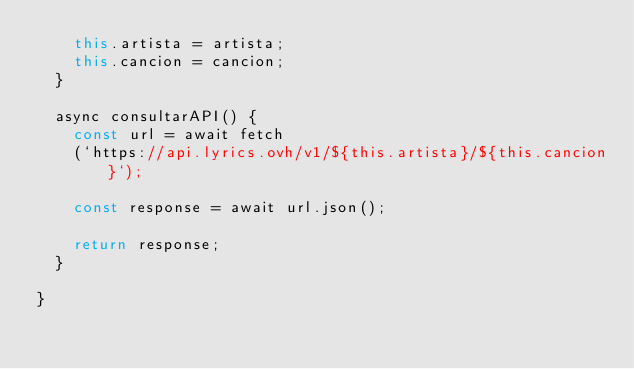<code> <loc_0><loc_0><loc_500><loc_500><_JavaScript_>    this.artista = artista;
    this.cancion = cancion;
  }

  async consultarAPI() {
    const url = await fetch
    (`https://api.lyrics.ovh/v1/${this.artista}/${this.cancion}`);

    const response = await url.json();

    return response;
  }

}</code> 